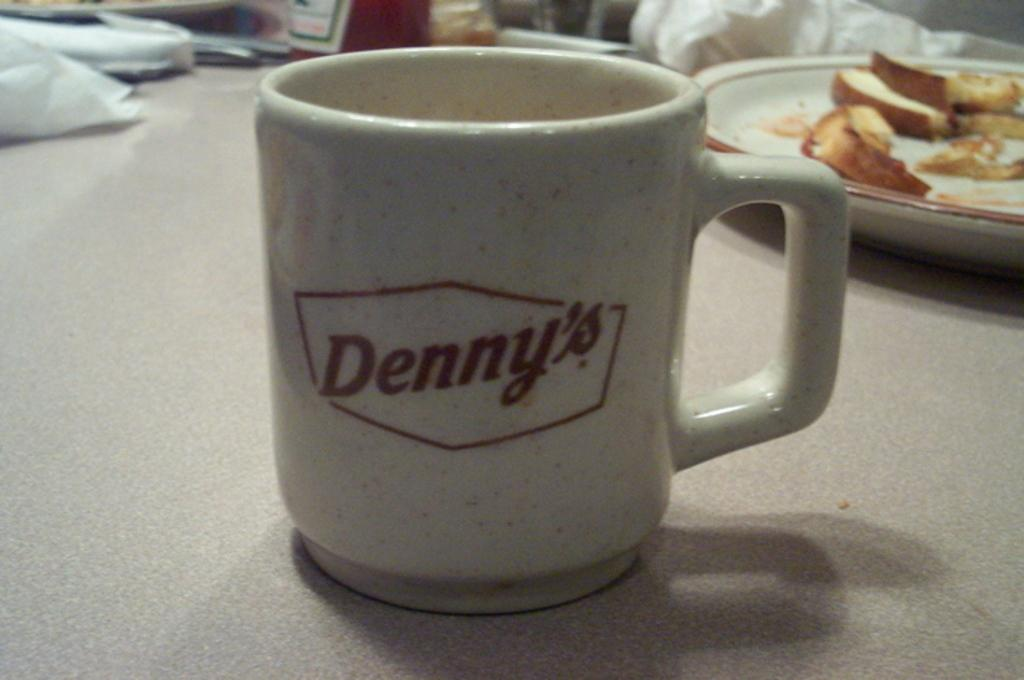<image>
Present a compact description of the photo's key features. A Denny's mug is sitting on a table with a plate of eaten food. 